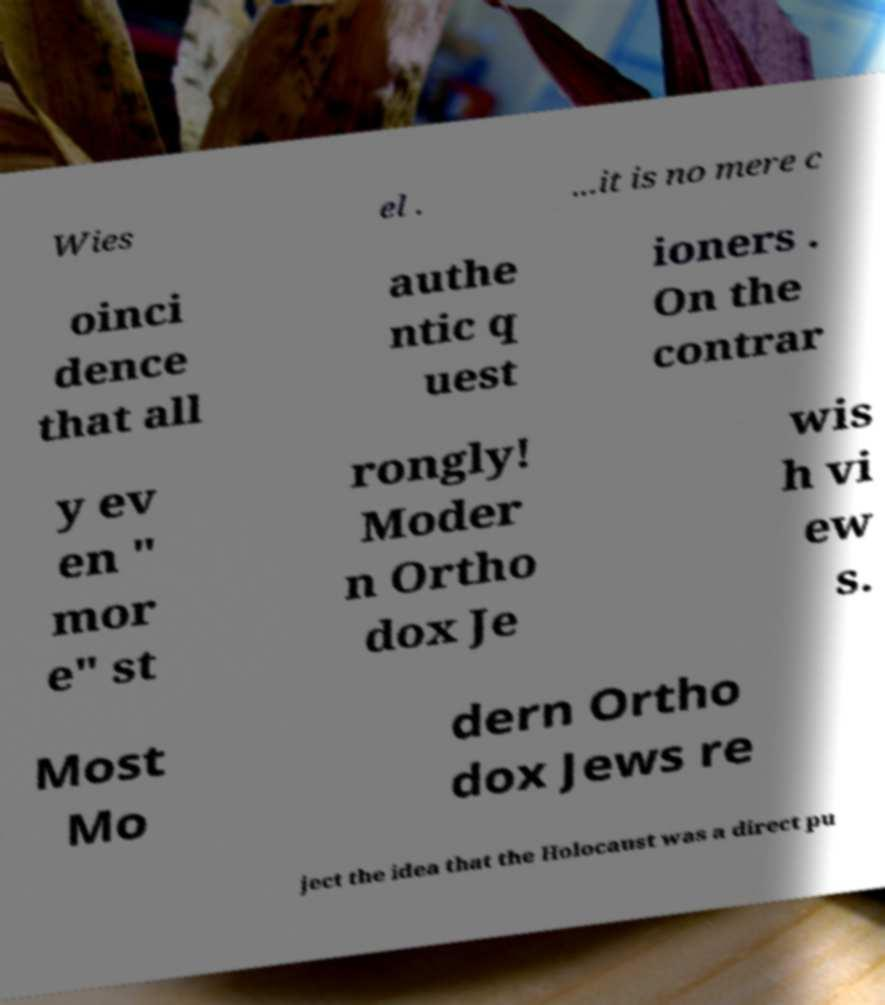Can you read and provide the text displayed in the image?This photo seems to have some interesting text. Can you extract and type it out for me? Wies el . ...it is no mere c oinci dence that all authe ntic q uest ioners . On the contrar y ev en " mor e" st rongly! Moder n Ortho dox Je wis h vi ew s. Most Mo dern Ortho dox Jews re ject the idea that the Holocaust was a direct pu 